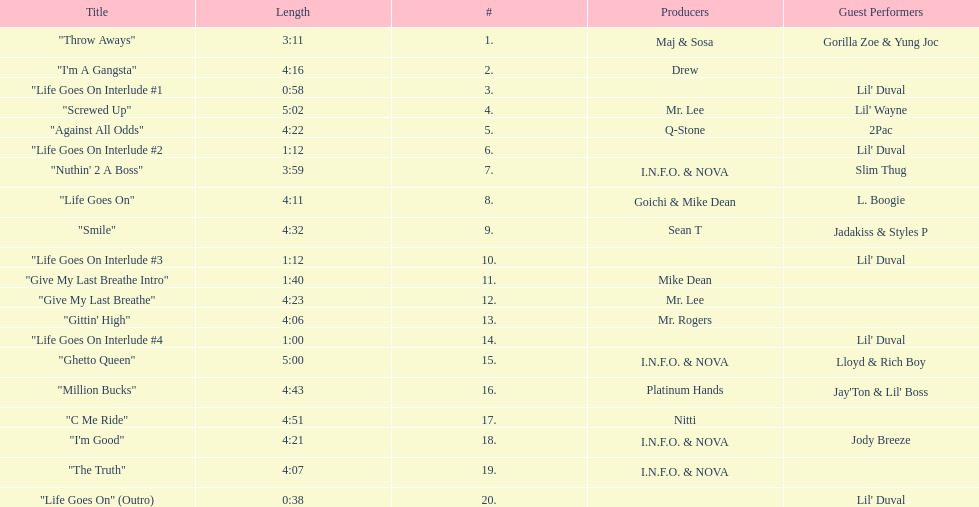Which tracks are longer than 4.00? "I'm A Gangsta", "Screwed Up", "Against All Odds", "Life Goes On", "Smile", "Give My Last Breathe", "Gittin' High", "Ghetto Queen", "Million Bucks", "C Me Ride", "I'm Good", "The Truth". Of those, which tracks are longer than 4.30? "Screwed Up", "Smile", "Ghetto Queen", "Million Bucks", "C Me Ride". Of those, which tracks are 5.00 or longer? "Screwed Up", "Ghetto Queen". Of those, which one is the longest? "Screwed Up". How long is that track? 5:02. 